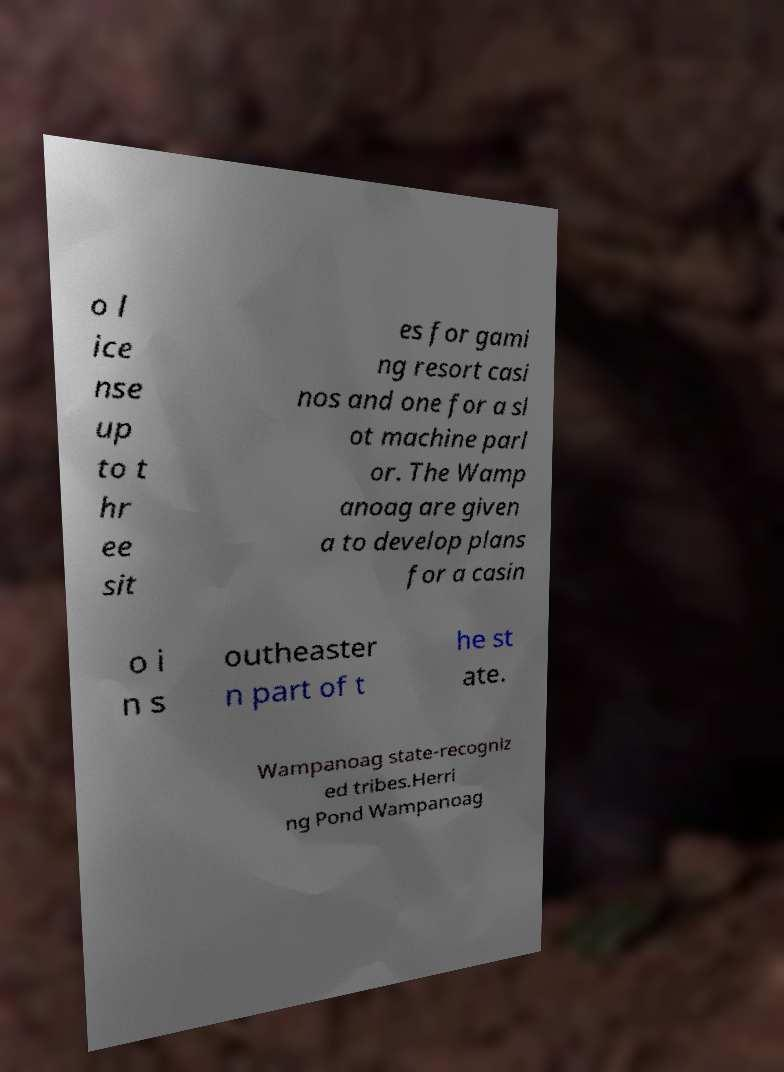Could you assist in decoding the text presented in this image and type it out clearly? o l ice nse up to t hr ee sit es for gami ng resort casi nos and one for a sl ot machine parl or. The Wamp anoag are given a to develop plans for a casin o i n s outheaster n part of t he st ate. Wampanoag state-recogniz ed tribes.Herri ng Pond Wampanoag 